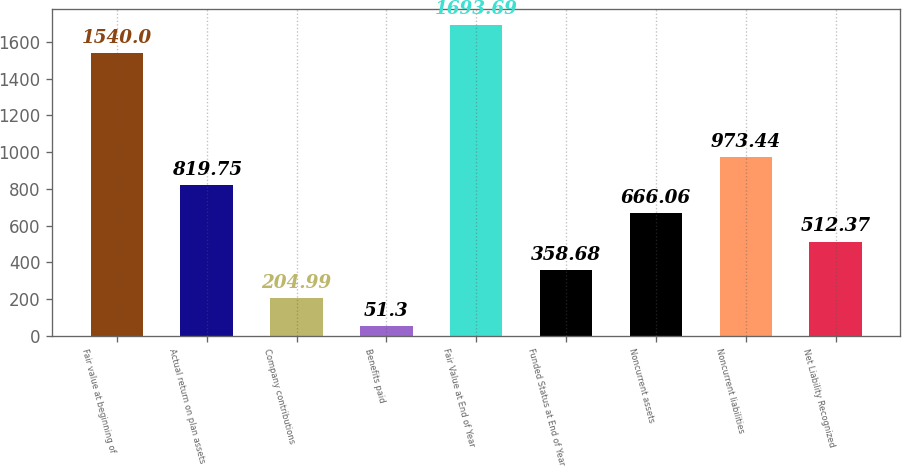Convert chart. <chart><loc_0><loc_0><loc_500><loc_500><bar_chart><fcel>Fair value at beginning of<fcel>Actual return on plan assets<fcel>Company contributions<fcel>Benefits paid<fcel>Fair Value at End of Year<fcel>Funded Status at End of Year<fcel>Noncurrent assets<fcel>Noncurrent liabilities<fcel>Net Liability Recognized<nl><fcel>1540<fcel>819.75<fcel>204.99<fcel>51.3<fcel>1693.69<fcel>358.68<fcel>666.06<fcel>973.44<fcel>512.37<nl></chart> 